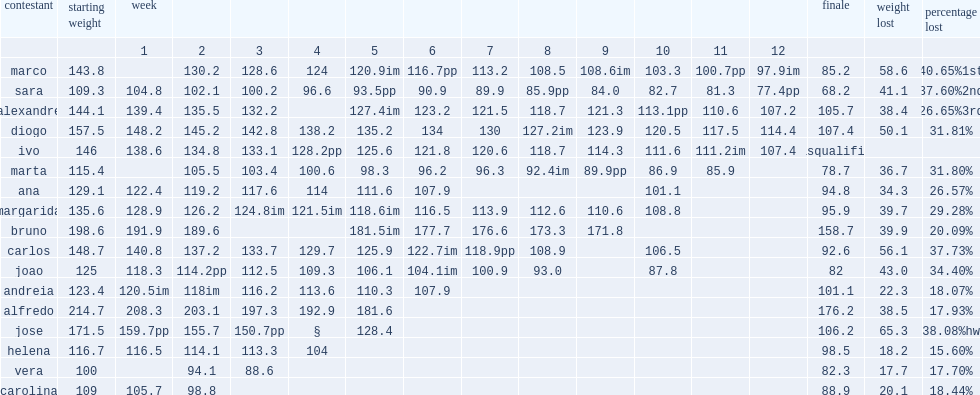The peso pesado 2 winner was marco, what was a total weight loss percentage of? 40.65%1st. The peso pesado 2 winner was marco, what was a total weight loss? 58.6. 